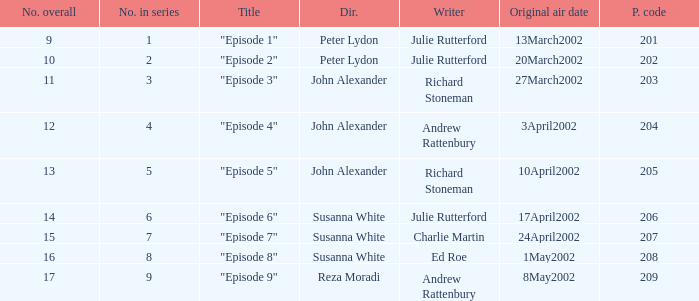When "episode 1" is the title what is the overall number? 9.0. 